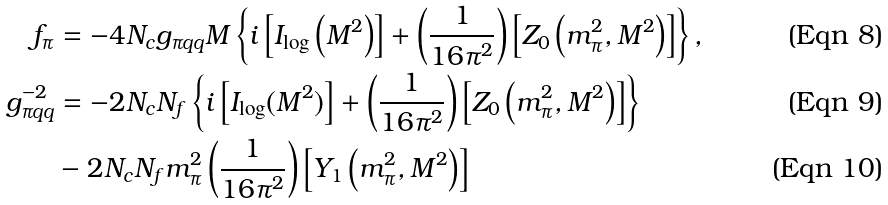Convert formula to latex. <formula><loc_0><loc_0><loc_500><loc_500>f _ { \pi } & = - 4 N _ { c } g _ { \pi q q } M \left \{ i \left [ I _ { \log } \left ( M ^ { 2 } \right ) \right ] + \left ( \frac { 1 } { 1 6 \pi ^ { 2 } } \right ) \left [ Z _ { 0 } \left ( m _ { \pi } ^ { 2 } , M ^ { 2 } \right ) \right ] \right \} , \\ g _ { \pi q q } ^ { - 2 } & = - 2 N _ { c } N _ { f } \left \{ i \left [ I _ { \log } ( M ^ { 2 } ) \right ] + \left ( \frac { 1 } { 1 6 \pi ^ { 2 } } \right ) \left [ Z _ { 0 } \left ( m _ { \pi } ^ { 2 } , M ^ { 2 } \right ) \right ] \right \} \\ & - 2 N _ { c } N _ { f } m _ { \pi } ^ { 2 } \left ( \frac { 1 } { 1 6 \pi ^ { 2 } } \right ) \left [ Y _ { 1 } \left ( m _ { \pi } ^ { 2 } , M ^ { 2 } \right ) \right ]</formula> 